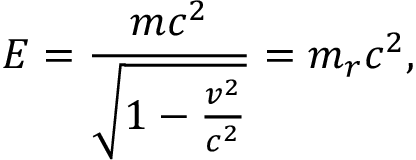Convert formula to latex. <formula><loc_0><loc_0><loc_500><loc_500>E = { \frac { m c ^ { 2 } } { \sqrt { 1 - { \frac { v ^ { 2 } } { c ^ { 2 } } } } } } = m _ { r } c ^ { 2 } ,</formula> 